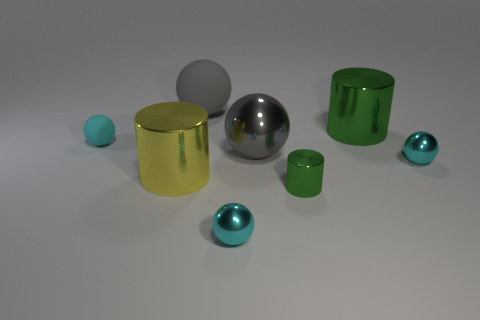There is a small metal object that is behind the small cylinder; is its color the same as the small rubber ball?
Provide a short and direct response. Yes. There is a tiny metallic ball right of the cyan metallic ball to the left of the green metallic object that is behind the yellow object; what color is it?
Make the answer very short. Cyan. The thing that is both left of the big rubber object and on the right side of the cyan rubber sphere has what shape?
Give a very brief answer. Cylinder. Is there anything else that is the same size as the gray metal object?
Your answer should be compact. Yes. What color is the matte sphere in front of the large sphere that is behind the big metal sphere?
Your answer should be very brief. Cyan. The cyan thing that is behind the ball that is on the right side of the green thing that is behind the small green metal cylinder is what shape?
Offer a very short reply. Sphere. There is a cyan sphere that is both on the right side of the yellow cylinder and behind the large yellow metallic object; what size is it?
Ensure brevity in your answer.  Small. What number of balls are the same color as the big matte object?
Your answer should be very brief. 1. What material is the big object that is the same color as the small metal cylinder?
Offer a very short reply. Metal. What is the large yellow cylinder made of?
Offer a very short reply. Metal. 